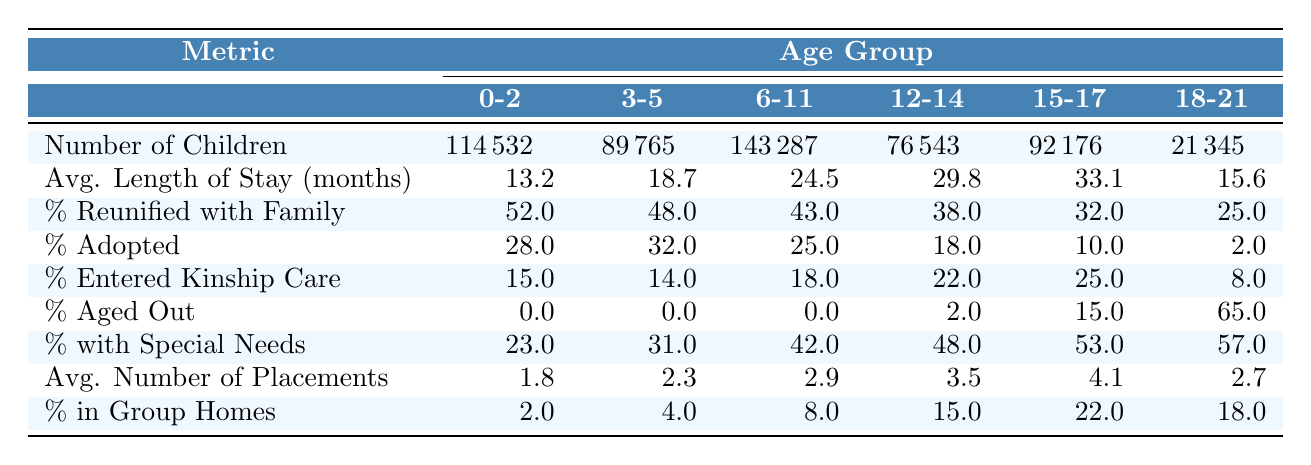What is the number of children in foster care aged 0-2 years? The number of children in the 0-2 years age group is directly listed in the table under the "Number of Children in Foster Care" row. It states 114,532.
Answer: 114532 What percentage of children aged 15-17 years are reunited with their family? The percentage of children reunited with their family for the 15-17 years age group is found in the "% Reunified with Family" row. It shows 32%.
Answer: 32% How many children aged 6-11 years are in foster care? The table provides the number of children in the 6-11 years age group in the "Number of Children in Foster Care" row, which is 143,287.
Answer: 143287 What is the average length of stay for children aged 12-14 years? For the 12-14 years age group, the average length of stay is given in the "Avg. Length of Stay (months)" row, which is 29.8 months.
Answer: 29.8 months Which age group has the highest percentage of special needs? The table categorically states the percentage of children with special needs for each age group. The 18-21 years group has the highest percentage at 57%.
Answer: 57% Which age group experiences the lowest percentage of adoption? The lowest percentage of adoption is found in the 18-21 years age group, where only 2% are adopted.
Answer: 2% What is the average number of placements for children aged 3-5 years compared to children aged 15-17 years? The average number of placements is listed for both age groups. For 3-5 years, it is 2.3, and for 15-17 years, it is 4.1. The difference can be calculated as 4.1 - 2.3 = 1.8, indicating that children aged 15-17 have more placements on average.
Answer: 1.8 more placements What percentage of children aged 12-14 years aged out of the foster care system? The percentage of children aged out for the 12-14 years group is indicated in the "% Aged Out" row in the table, which shows 2%.
Answer: 2% What is the total number of children in foster care across all age groups? To get the total, sum all the numbers from the "Number of Children in Foster Care" row: 114532 + 89765 + 143287 + 76543 + 92176 + 21345 = 499648.
Answer: 499648 Which age group has the highest percentage of children in group homes? The percentage of children in group homes is stated for each age group, and the 15-17 years age group has the highest at 22%.
Answer: 22% If a child aged 18-21 years has a special need, what is the probability they will be adopted? The percentage of children who are adopted in the 18-21 years group is 2%, while the percentage with special needs is 57%. The probability of being adopted given a special need is approximately 2%, as adoption rates are independent of special needs status.
Answer: 2% 